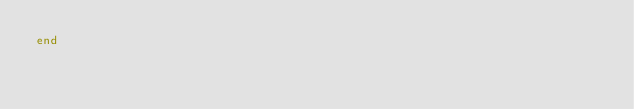<code> <loc_0><loc_0><loc_500><loc_500><_Ruby_>end
</code> 